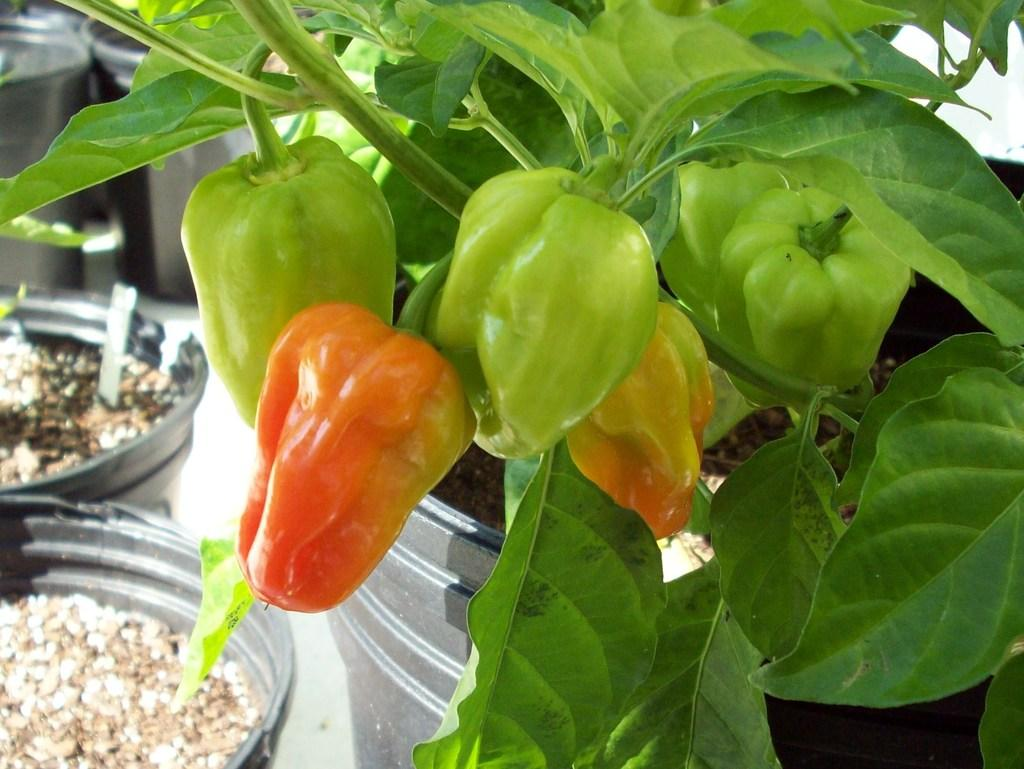What type of plant is visible in the image? There is a plant in the image. What other types of vegetation can be seen in the image? There are vegetables in the image. Can you identify any specific vegetables in the image? Yes, there are potatoes in the image. Where are all the mentioned objects located in the image? All the mentioned objects, including the plant, vegetables, and potatoes, are on the surface. What type of bedroom can be seen in the image? There is no bedroom present in the image; it features a plant, vegetables, and potatoes on a surface. What need is being fulfilled by the objects in the image? There is no specific need being fulfilled by the objects in the image; they are simply visible on a surface. 